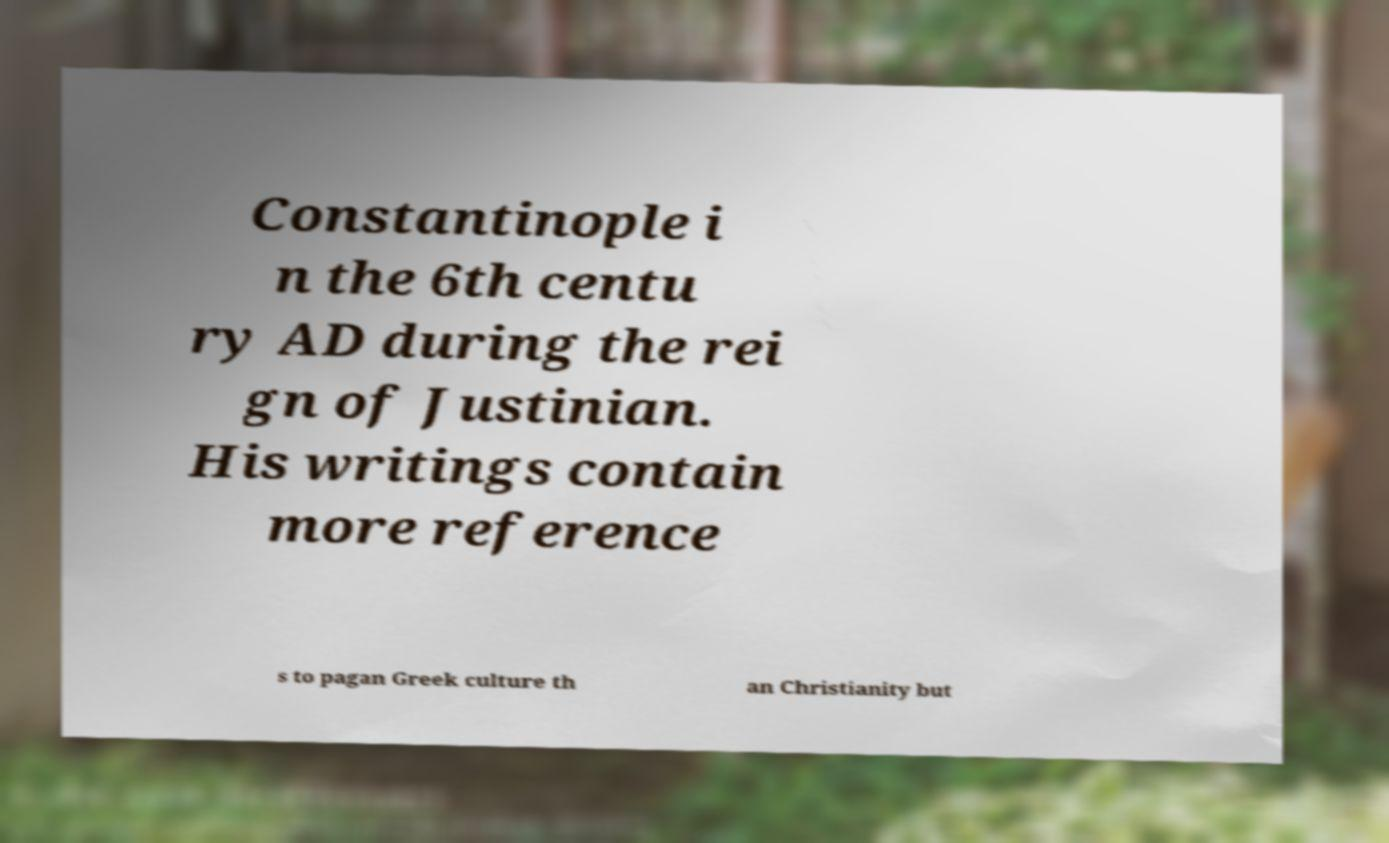I need the written content from this picture converted into text. Can you do that? Constantinople i n the 6th centu ry AD during the rei gn of Justinian. His writings contain more reference s to pagan Greek culture th an Christianity but 